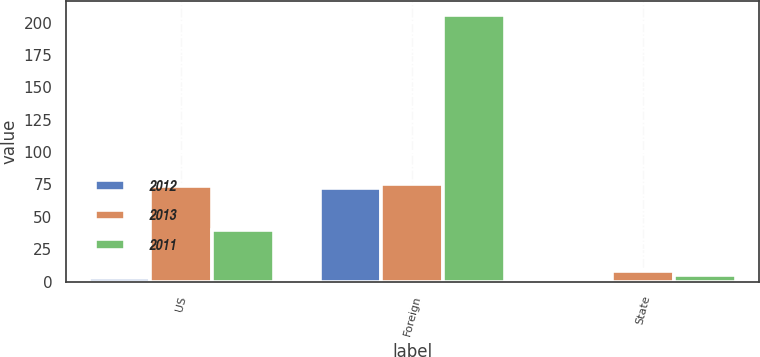Convert chart to OTSL. <chart><loc_0><loc_0><loc_500><loc_500><stacked_bar_chart><ecel><fcel>US<fcel>Foreign<fcel>State<nl><fcel>2012<fcel>3<fcel>72<fcel>2<nl><fcel>2013<fcel>74<fcel>75<fcel>8<nl><fcel>2011<fcel>40<fcel>206<fcel>5<nl></chart> 